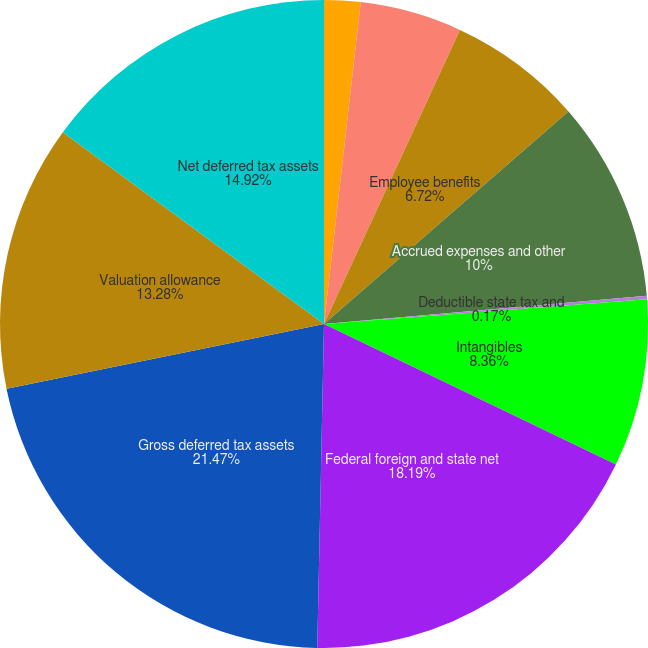Convert chart. <chart><loc_0><loc_0><loc_500><loc_500><pie_chart><fcel>Accounts receivable<fcel>Inventories<fcel>Employee benefits<fcel>Accrued expenses and other<fcel>Deductible state tax and<fcel>Intangibles<fcel>Federal foreign and state net<fcel>Gross deferred tax assets<fcel>Valuation allowance<fcel>Net deferred tax assets<nl><fcel>1.81%<fcel>5.08%<fcel>6.72%<fcel>10.0%<fcel>0.17%<fcel>8.36%<fcel>18.19%<fcel>21.47%<fcel>13.28%<fcel>14.92%<nl></chart> 